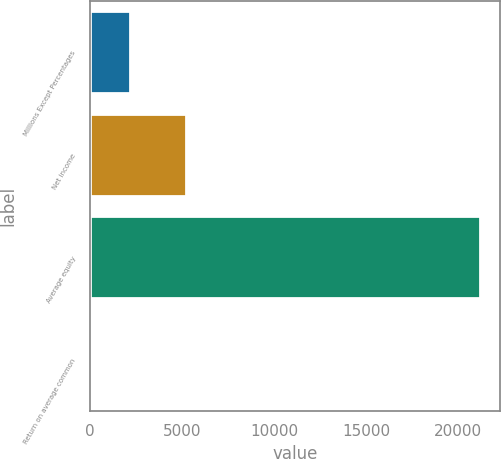Convert chart to OTSL. <chart><loc_0><loc_0><loc_500><loc_500><bar_chart><fcel>Millions Except Percentages<fcel>Net income<fcel>Average equity<fcel>Return on average common<nl><fcel>2142.66<fcel>5180<fcel>21207<fcel>24.4<nl></chart> 